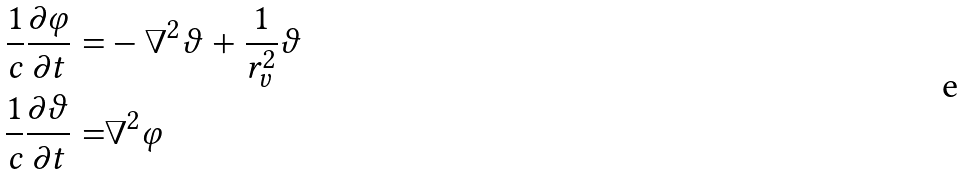<formula> <loc_0><loc_0><loc_500><loc_500>\frac { 1 } { c } \frac { \partial \varphi } { \partial t } = & - \nabla ^ { 2 } \vartheta + \frac { 1 } { r _ { v } ^ { 2 } } \vartheta \\ \frac { 1 } { c } \frac { \partial \vartheta } { \partial t } = & \nabla ^ { 2 } \varphi</formula> 